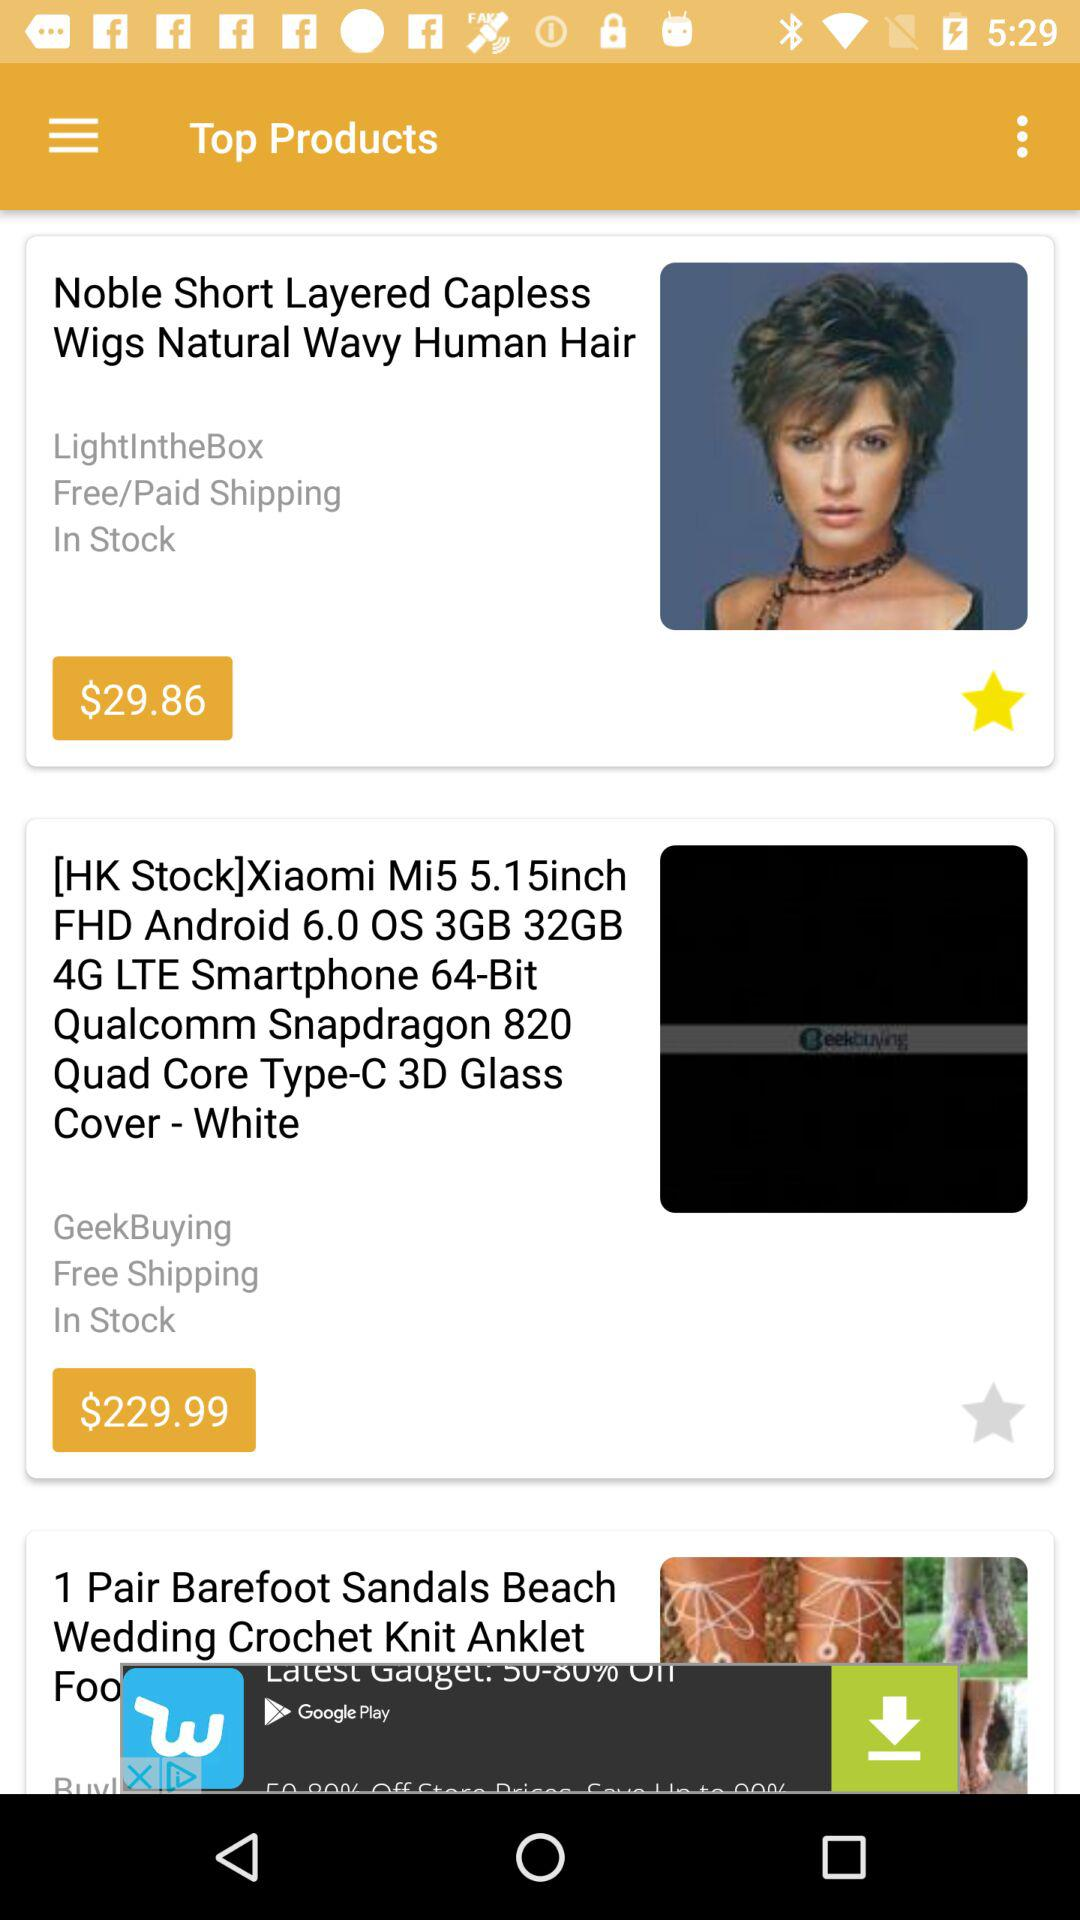Which products are in stock? The products "Noble Short Layered Capless Wigs Natural Wavy Human Hair" and "[HK Stock]Xiaomi Mi5 5.15inch FHD Android 6.0 OS 3GB 32GB 4G LTE Smartphone 64-Bit Qualcomm Snapdragon 820 Quad Core Type-C 3D Glass Cover - White" are in stock. 